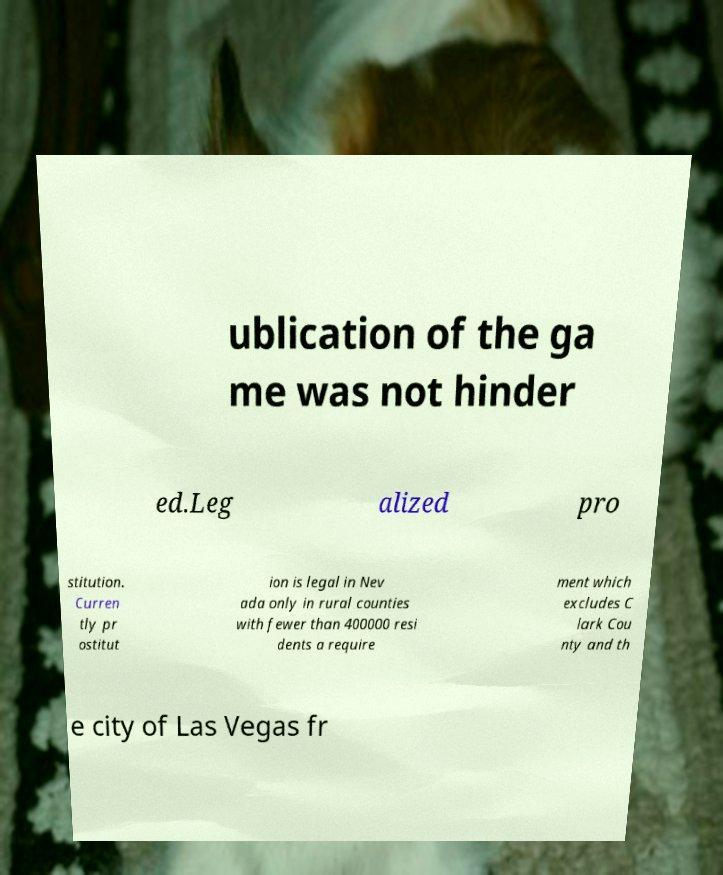Please identify and transcribe the text found in this image. ublication of the ga me was not hinder ed.Leg alized pro stitution. Curren tly pr ostitut ion is legal in Nev ada only in rural counties with fewer than 400000 resi dents a require ment which excludes C lark Cou nty and th e city of Las Vegas fr 